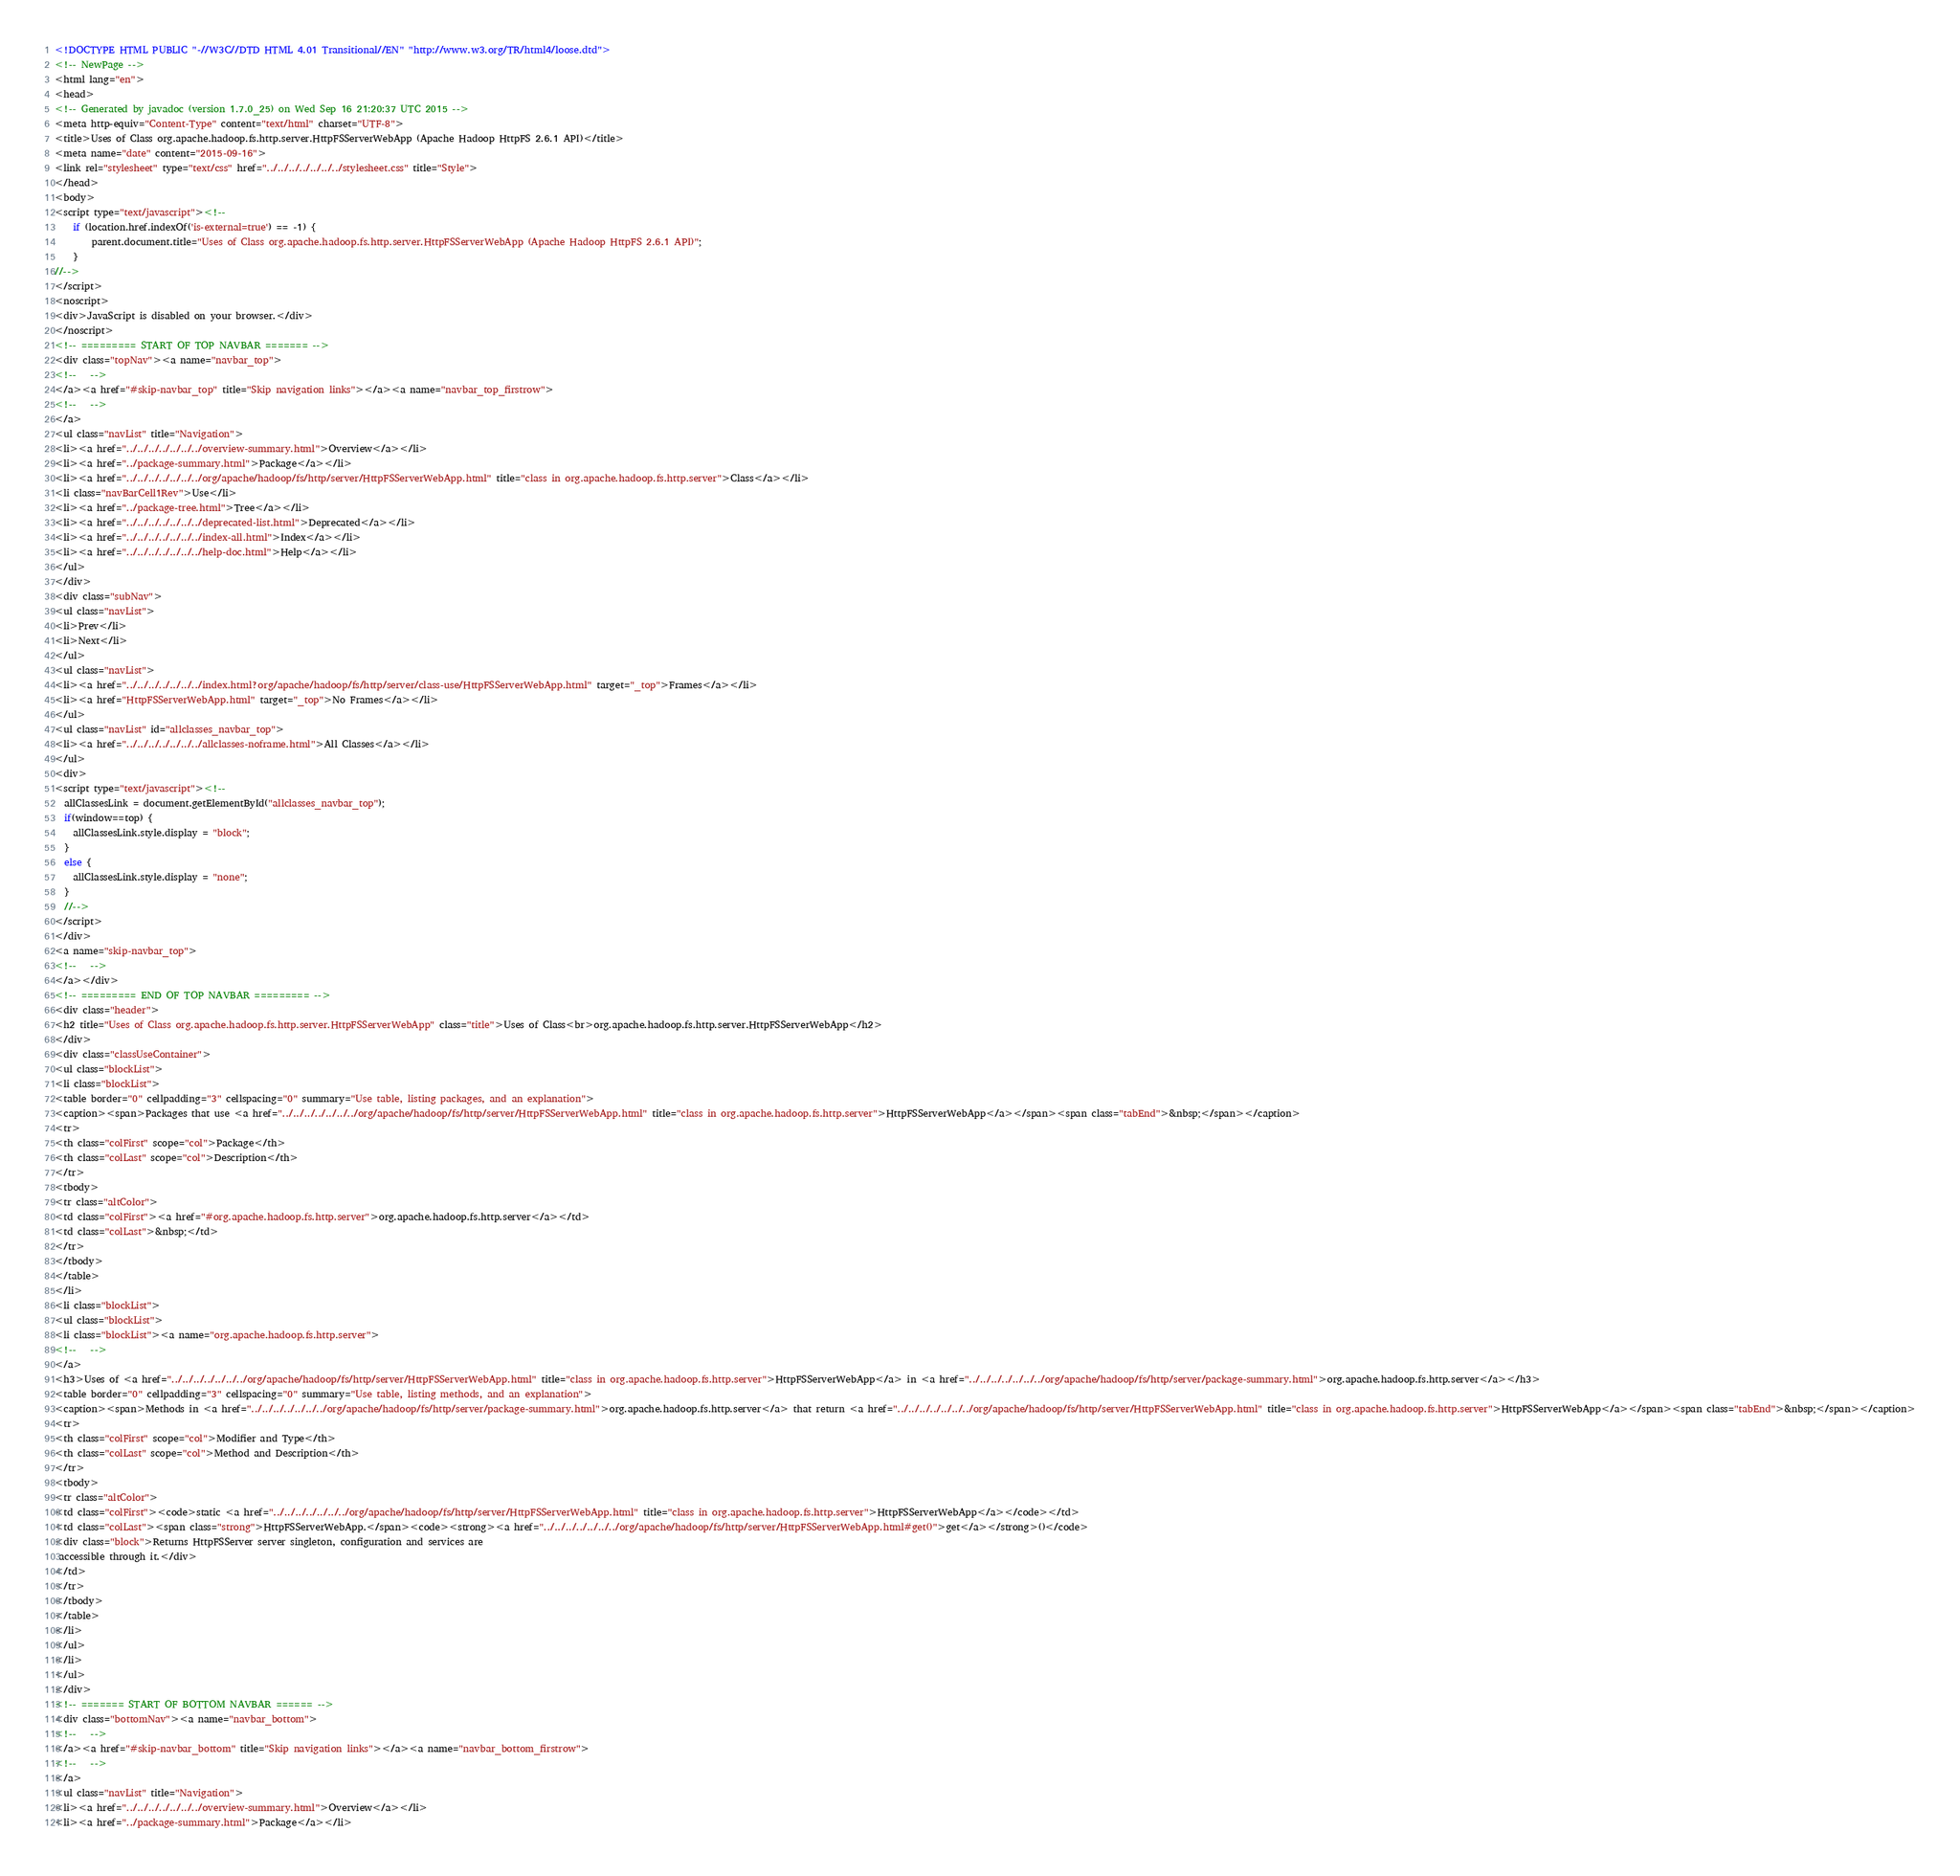Convert code to text. <code><loc_0><loc_0><loc_500><loc_500><_HTML_><!DOCTYPE HTML PUBLIC "-//W3C//DTD HTML 4.01 Transitional//EN" "http://www.w3.org/TR/html4/loose.dtd">
<!-- NewPage -->
<html lang="en">
<head>
<!-- Generated by javadoc (version 1.7.0_25) on Wed Sep 16 21:20:37 UTC 2015 -->
<meta http-equiv="Content-Type" content="text/html" charset="UTF-8">
<title>Uses of Class org.apache.hadoop.fs.http.server.HttpFSServerWebApp (Apache Hadoop HttpFS 2.6.1 API)</title>
<meta name="date" content="2015-09-16">
<link rel="stylesheet" type="text/css" href="../../../../../../../stylesheet.css" title="Style">
</head>
<body>
<script type="text/javascript"><!--
    if (location.href.indexOf('is-external=true') == -1) {
        parent.document.title="Uses of Class org.apache.hadoop.fs.http.server.HttpFSServerWebApp (Apache Hadoop HttpFS 2.6.1 API)";
    }
//-->
</script>
<noscript>
<div>JavaScript is disabled on your browser.</div>
</noscript>
<!-- ========= START OF TOP NAVBAR ======= -->
<div class="topNav"><a name="navbar_top">
<!--   -->
</a><a href="#skip-navbar_top" title="Skip navigation links"></a><a name="navbar_top_firstrow">
<!--   -->
</a>
<ul class="navList" title="Navigation">
<li><a href="../../../../../../../overview-summary.html">Overview</a></li>
<li><a href="../package-summary.html">Package</a></li>
<li><a href="../../../../../../../org/apache/hadoop/fs/http/server/HttpFSServerWebApp.html" title="class in org.apache.hadoop.fs.http.server">Class</a></li>
<li class="navBarCell1Rev">Use</li>
<li><a href="../package-tree.html">Tree</a></li>
<li><a href="../../../../../../../deprecated-list.html">Deprecated</a></li>
<li><a href="../../../../../../../index-all.html">Index</a></li>
<li><a href="../../../../../../../help-doc.html">Help</a></li>
</ul>
</div>
<div class="subNav">
<ul class="navList">
<li>Prev</li>
<li>Next</li>
</ul>
<ul class="navList">
<li><a href="../../../../../../../index.html?org/apache/hadoop/fs/http/server/class-use/HttpFSServerWebApp.html" target="_top">Frames</a></li>
<li><a href="HttpFSServerWebApp.html" target="_top">No Frames</a></li>
</ul>
<ul class="navList" id="allclasses_navbar_top">
<li><a href="../../../../../../../allclasses-noframe.html">All Classes</a></li>
</ul>
<div>
<script type="text/javascript"><!--
  allClassesLink = document.getElementById("allclasses_navbar_top");
  if(window==top) {
    allClassesLink.style.display = "block";
  }
  else {
    allClassesLink.style.display = "none";
  }
  //-->
</script>
</div>
<a name="skip-navbar_top">
<!--   -->
</a></div>
<!-- ========= END OF TOP NAVBAR ========= -->
<div class="header">
<h2 title="Uses of Class org.apache.hadoop.fs.http.server.HttpFSServerWebApp" class="title">Uses of Class<br>org.apache.hadoop.fs.http.server.HttpFSServerWebApp</h2>
</div>
<div class="classUseContainer">
<ul class="blockList">
<li class="blockList">
<table border="0" cellpadding="3" cellspacing="0" summary="Use table, listing packages, and an explanation">
<caption><span>Packages that use <a href="../../../../../../../org/apache/hadoop/fs/http/server/HttpFSServerWebApp.html" title="class in org.apache.hadoop.fs.http.server">HttpFSServerWebApp</a></span><span class="tabEnd">&nbsp;</span></caption>
<tr>
<th class="colFirst" scope="col">Package</th>
<th class="colLast" scope="col">Description</th>
</tr>
<tbody>
<tr class="altColor">
<td class="colFirst"><a href="#org.apache.hadoop.fs.http.server">org.apache.hadoop.fs.http.server</a></td>
<td class="colLast">&nbsp;</td>
</tr>
</tbody>
</table>
</li>
<li class="blockList">
<ul class="blockList">
<li class="blockList"><a name="org.apache.hadoop.fs.http.server">
<!--   -->
</a>
<h3>Uses of <a href="../../../../../../../org/apache/hadoop/fs/http/server/HttpFSServerWebApp.html" title="class in org.apache.hadoop.fs.http.server">HttpFSServerWebApp</a> in <a href="../../../../../../../org/apache/hadoop/fs/http/server/package-summary.html">org.apache.hadoop.fs.http.server</a></h3>
<table border="0" cellpadding="3" cellspacing="0" summary="Use table, listing methods, and an explanation">
<caption><span>Methods in <a href="../../../../../../../org/apache/hadoop/fs/http/server/package-summary.html">org.apache.hadoop.fs.http.server</a> that return <a href="../../../../../../../org/apache/hadoop/fs/http/server/HttpFSServerWebApp.html" title="class in org.apache.hadoop.fs.http.server">HttpFSServerWebApp</a></span><span class="tabEnd">&nbsp;</span></caption>
<tr>
<th class="colFirst" scope="col">Modifier and Type</th>
<th class="colLast" scope="col">Method and Description</th>
</tr>
<tbody>
<tr class="altColor">
<td class="colFirst"><code>static <a href="../../../../../../../org/apache/hadoop/fs/http/server/HttpFSServerWebApp.html" title="class in org.apache.hadoop.fs.http.server">HttpFSServerWebApp</a></code></td>
<td class="colLast"><span class="strong">HttpFSServerWebApp.</span><code><strong><a href="../../../../../../../org/apache/hadoop/fs/http/server/HttpFSServerWebApp.html#get()">get</a></strong>()</code>
<div class="block">Returns HttpFSServer server singleton, configuration and services are
 accessible through it.</div>
</td>
</tr>
</tbody>
</table>
</li>
</ul>
</li>
</ul>
</div>
<!-- ======= START OF BOTTOM NAVBAR ====== -->
<div class="bottomNav"><a name="navbar_bottom">
<!--   -->
</a><a href="#skip-navbar_bottom" title="Skip navigation links"></a><a name="navbar_bottom_firstrow">
<!--   -->
</a>
<ul class="navList" title="Navigation">
<li><a href="../../../../../../../overview-summary.html">Overview</a></li>
<li><a href="../package-summary.html">Package</a></li></code> 